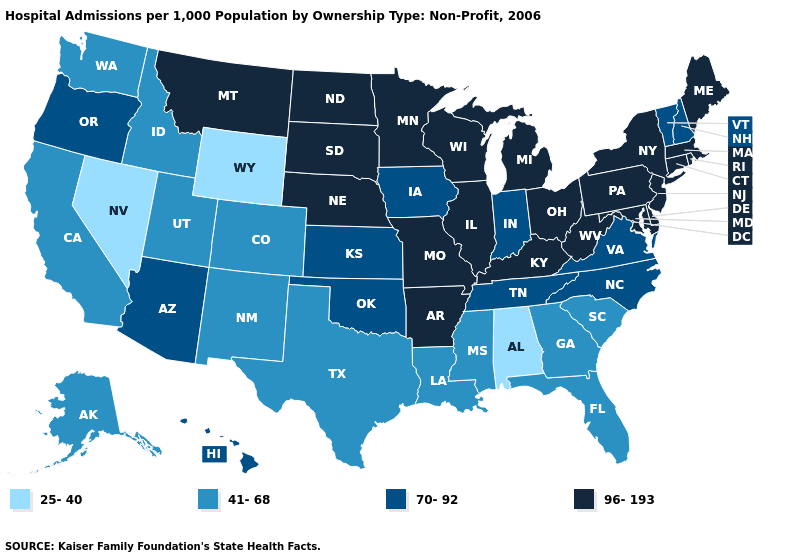What is the value of New York?
Be succinct. 96-193. What is the value of Mississippi?
Keep it brief. 41-68. Name the states that have a value in the range 41-68?
Concise answer only. Alaska, California, Colorado, Florida, Georgia, Idaho, Louisiana, Mississippi, New Mexico, South Carolina, Texas, Utah, Washington. Does the first symbol in the legend represent the smallest category?
Give a very brief answer. Yes. What is the value of Massachusetts?
Be succinct. 96-193. Which states have the lowest value in the USA?
Answer briefly. Alabama, Nevada, Wyoming. What is the value of Hawaii?
Short answer required. 70-92. How many symbols are there in the legend?
Keep it brief. 4. Name the states that have a value in the range 96-193?
Short answer required. Arkansas, Connecticut, Delaware, Illinois, Kentucky, Maine, Maryland, Massachusetts, Michigan, Minnesota, Missouri, Montana, Nebraska, New Jersey, New York, North Dakota, Ohio, Pennsylvania, Rhode Island, South Dakota, West Virginia, Wisconsin. Name the states that have a value in the range 41-68?
Concise answer only. Alaska, California, Colorado, Florida, Georgia, Idaho, Louisiana, Mississippi, New Mexico, South Carolina, Texas, Utah, Washington. What is the value of Pennsylvania?
Give a very brief answer. 96-193. Which states have the highest value in the USA?
Write a very short answer. Arkansas, Connecticut, Delaware, Illinois, Kentucky, Maine, Maryland, Massachusetts, Michigan, Minnesota, Missouri, Montana, Nebraska, New Jersey, New York, North Dakota, Ohio, Pennsylvania, Rhode Island, South Dakota, West Virginia, Wisconsin. Name the states that have a value in the range 41-68?
Be succinct. Alaska, California, Colorado, Florida, Georgia, Idaho, Louisiana, Mississippi, New Mexico, South Carolina, Texas, Utah, Washington. What is the lowest value in states that border Montana?
Quick response, please. 25-40. 